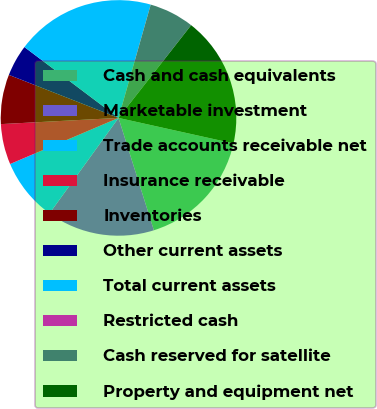<chart> <loc_0><loc_0><loc_500><loc_500><pie_chart><fcel>Cash and cash equivalents<fcel>Marketable investment<fcel>Trade accounts receivable net<fcel>Insurance receivable<fcel>Inventories<fcel>Other current assets<fcel>Total current assets<fcel>Restricted cash<fcel>Cash reserved for satellite<fcel>Property and equipment net<nl><fcel>16.67%<fcel>14.81%<fcel>8.64%<fcel>5.56%<fcel>6.79%<fcel>4.32%<fcel>19.13%<fcel>0.0%<fcel>6.17%<fcel>17.9%<nl></chart> 